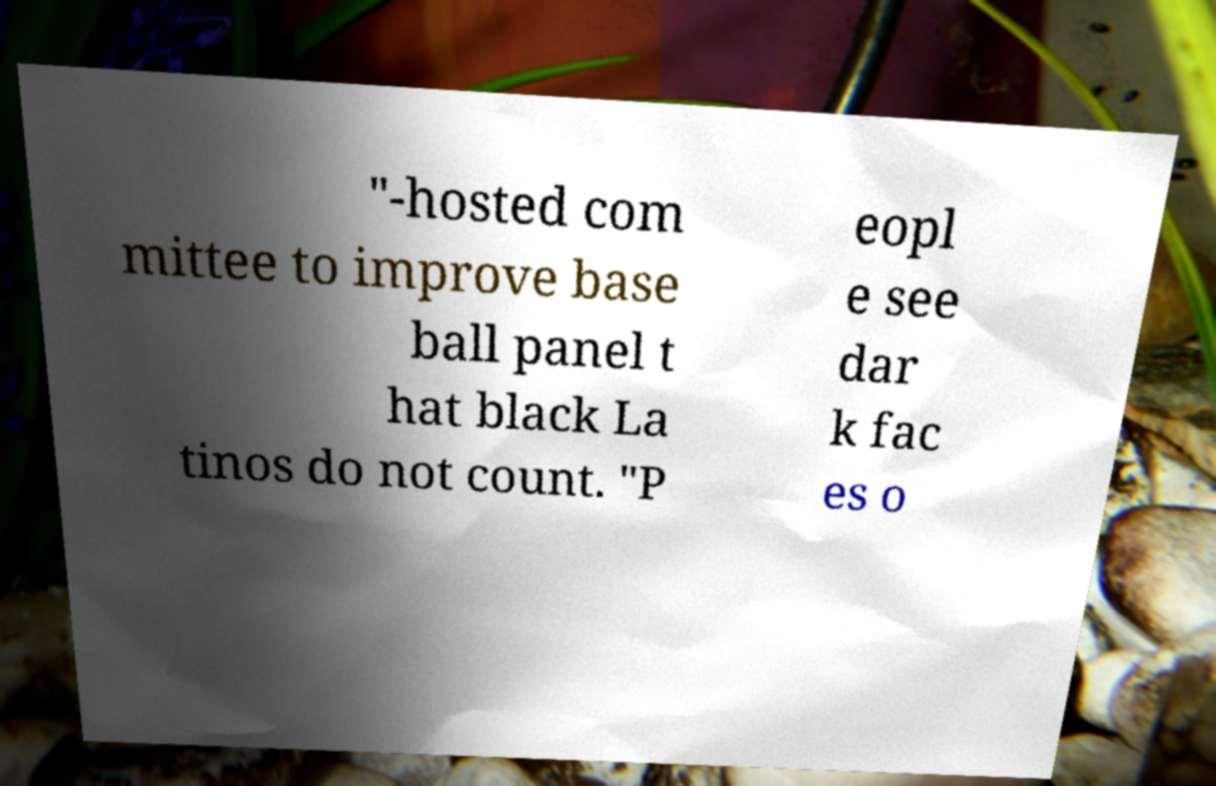I need the written content from this picture converted into text. Can you do that? "-hosted com mittee to improve base ball panel t hat black La tinos do not count. "P eopl e see dar k fac es o 